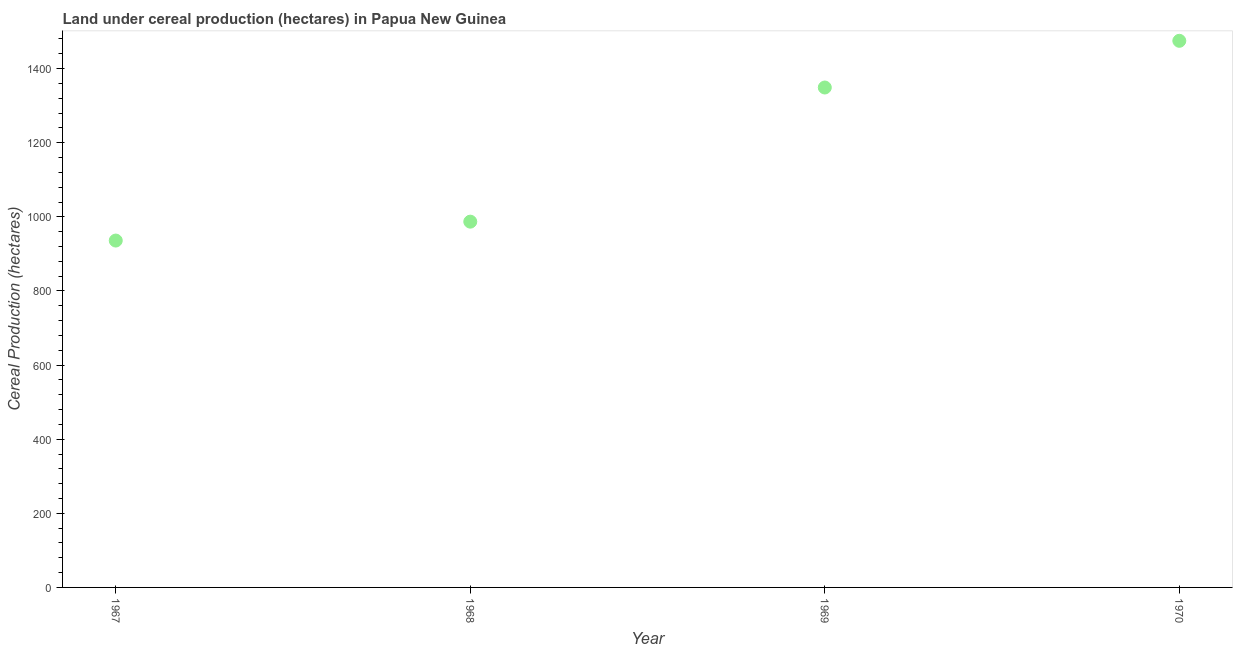What is the land under cereal production in 1970?
Your response must be concise. 1475. Across all years, what is the maximum land under cereal production?
Offer a terse response. 1475. Across all years, what is the minimum land under cereal production?
Make the answer very short. 936. In which year was the land under cereal production maximum?
Provide a short and direct response. 1970. In which year was the land under cereal production minimum?
Provide a short and direct response. 1967. What is the sum of the land under cereal production?
Offer a very short reply. 4747. What is the difference between the land under cereal production in 1967 and 1968?
Give a very brief answer. -51. What is the average land under cereal production per year?
Provide a succinct answer. 1186.75. What is the median land under cereal production?
Provide a succinct answer. 1168. What is the ratio of the land under cereal production in 1969 to that in 1970?
Give a very brief answer. 0.91. Is the difference between the land under cereal production in 1968 and 1969 greater than the difference between any two years?
Give a very brief answer. No. What is the difference between the highest and the second highest land under cereal production?
Provide a short and direct response. 126. Is the sum of the land under cereal production in 1967 and 1968 greater than the maximum land under cereal production across all years?
Give a very brief answer. Yes. What is the difference between the highest and the lowest land under cereal production?
Offer a terse response. 539. Does the land under cereal production monotonically increase over the years?
Offer a very short reply. Yes. How many years are there in the graph?
Give a very brief answer. 4. What is the difference between two consecutive major ticks on the Y-axis?
Offer a terse response. 200. Are the values on the major ticks of Y-axis written in scientific E-notation?
Provide a short and direct response. No. Does the graph contain grids?
Your response must be concise. No. What is the title of the graph?
Keep it short and to the point. Land under cereal production (hectares) in Papua New Guinea. What is the label or title of the X-axis?
Your response must be concise. Year. What is the label or title of the Y-axis?
Provide a succinct answer. Cereal Production (hectares). What is the Cereal Production (hectares) in 1967?
Keep it short and to the point. 936. What is the Cereal Production (hectares) in 1968?
Offer a very short reply. 987. What is the Cereal Production (hectares) in 1969?
Make the answer very short. 1349. What is the Cereal Production (hectares) in 1970?
Make the answer very short. 1475. What is the difference between the Cereal Production (hectares) in 1967 and 1968?
Provide a short and direct response. -51. What is the difference between the Cereal Production (hectares) in 1967 and 1969?
Your response must be concise. -413. What is the difference between the Cereal Production (hectares) in 1967 and 1970?
Ensure brevity in your answer.  -539. What is the difference between the Cereal Production (hectares) in 1968 and 1969?
Make the answer very short. -362. What is the difference between the Cereal Production (hectares) in 1968 and 1970?
Your answer should be very brief. -488. What is the difference between the Cereal Production (hectares) in 1969 and 1970?
Ensure brevity in your answer.  -126. What is the ratio of the Cereal Production (hectares) in 1967 to that in 1968?
Provide a succinct answer. 0.95. What is the ratio of the Cereal Production (hectares) in 1967 to that in 1969?
Provide a short and direct response. 0.69. What is the ratio of the Cereal Production (hectares) in 1967 to that in 1970?
Provide a succinct answer. 0.64. What is the ratio of the Cereal Production (hectares) in 1968 to that in 1969?
Keep it short and to the point. 0.73. What is the ratio of the Cereal Production (hectares) in 1968 to that in 1970?
Provide a succinct answer. 0.67. What is the ratio of the Cereal Production (hectares) in 1969 to that in 1970?
Offer a terse response. 0.92. 